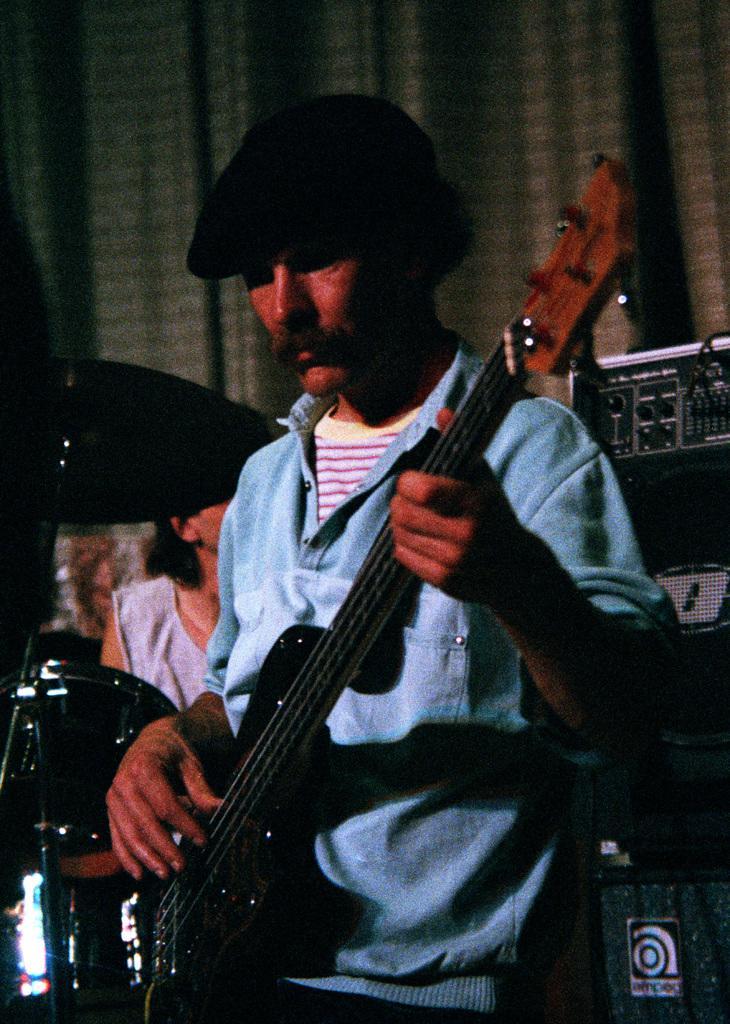Please provide a concise description of this image. In the center of the image there is a man holding a guitar in his hand. He is wearing a cap. In the background there is a band, speakers and curtain. 